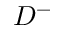<formula> <loc_0><loc_0><loc_500><loc_500>D ^ { - }</formula> 